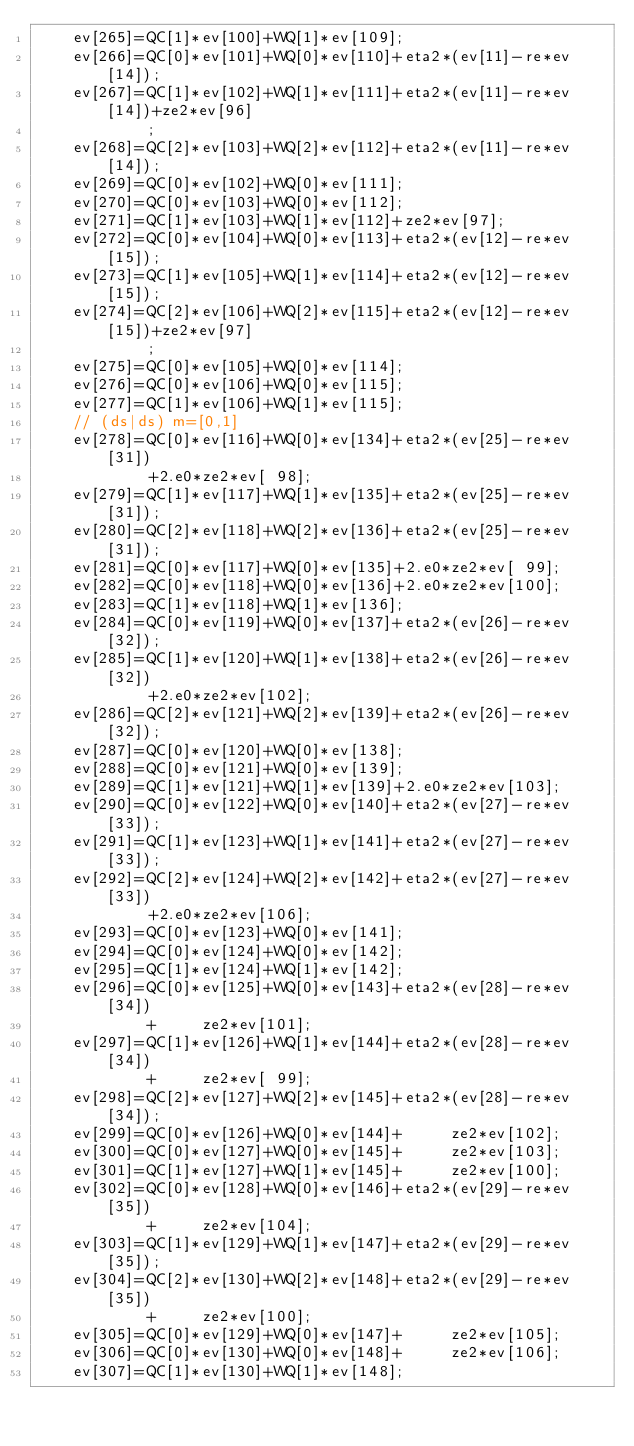<code> <loc_0><loc_0><loc_500><loc_500><_Cuda_>    ev[265]=QC[1]*ev[100]+WQ[1]*ev[109];
    ev[266]=QC[0]*ev[101]+WQ[0]*ev[110]+eta2*(ev[11]-re*ev[14]);
    ev[267]=QC[1]*ev[102]+WQ[1]*ev[111]+eta2*(ev[11]-re*ev[14])+ze2*ev[96]
            ;
    ev[268]=QC[2]*ev[103]+WQ[2]*ev[112]+eta2*(ev[11]-re*ev[14]);
    ev[269]=QC[0]*ev[102]+WQ[0]*ev[111];
    ev[270]=QC[0]*ev[103]+WQ[0]*ev[112];
    ev[271]=QC[1]*ev[103]+WQ[1]*ev[112]+ze2*ev[97];
    ev[272]=QC[0]*ev[104]+WQ[0]*ev[113]+eta2*(ev[12]-re*ev[15]);
    ev[273]=QC[1]*ev[105]+WQ[1]*ev[114]+eta2*(ev[12]-re*ev[15]);
    ev[274]=QC[2]*ev[106]+WQ[2]*ev[115]+eta2*(ev[12]-re*ev[15])+ze2*ev[97]
            ;
    ev[275]=QC[0]*ev[105]+WQ[0]*ev[114];
    ev[276]=QC[0]*ev[106]+WQ[0]*ev[115];
    ev[277]=QC[1]*ev[106]+WQ[1]*ev[115];
    // (ds|ds) m=[0,1]
    ev[278]=QC[0]*ev[116]+WQ[0]*ev[134]+eta2*(ev[25]-re*ev[31])
            +2.e0*ze2*ev[ 98];
    ev[279]=QC[1]*ev[117]+WQ[1]*ev[135]+eta2*(ev[25]-re*ev[31]);
    ev[280]=QC[2]*ev[118]+WQ[2]*ev[136]+eta2*(ev[25]-re*ev[31]);
    ev[281]=QC[0]*ev[117]+WQ[0]*ev[135]+2.e0*ze2*ev[ 99];
    ev[282]=QC[0]*ev[118]+WQ[0]*ev[136]+2.e0*ze2*ev[100];
    ev[283]=QC[1]*ev[118]+WQ[1]*ev[136];
    ev[284]=QC[0]*ev[119]+WQ[0]*ev[137]+eta2*(ev[26]-re*ev[32]);
    ev[285]=QC[1]*ev[120]+WQ[1]*ev[138]+eta2*(ev[26]-re*ev[32])
            +2.e0*ze2*ev[102];
    ev[286]=QC[2]*ev[121]+WQ[2]*ev[139]+eta2*(ev[26]-re*ev[32]);
    ev[287]=QC[0]*ev[120]+WQ[0]*ev[138];
    ev[288]=QC[0]*ev[121]+WQ[0]*ev[139];
    ev[289]=QC[1]*ev[121]+WQ[1]*ev[139]+2.e0*ze2*ev[103];
    ev[290]=QC[0]*ev[122]+WQ[0]*ev[140]+eta2*(ev[27]-re*ev[33]);
    ev[291]=QC[1]*ev[123]+WQ[1]*ev[141]+eta2*(ev[27]-re*ev[33]);
    ev[292]=QC[2]*ev[124]+WQ[2]*ev[142]+eta2*(ev[27]-re*ev[33])
            +2.e0*ze2*ev[106];
    ev[293]=QC[0]*ev[123]+WQ[0]*ev[141];
    ev[294]=QC[0]*ev[124]+WQ[0]*ev[142];
    ev[295]=QC[1]*ev[124]+WQ[1]*ev[142];
    ev[296]=QC[0]*ev[125]+WQ[0]*ev[143]+eta2*(ev[28]-re*ev[34])
            +     ze2*ev[101];
    ev[297]=QC[1]*ev[126]+WQ[1]*ev[144]+eta2*(ev[28]-re*ev[34])
            +     ze2*ev[ 99];
    ev[298]=QC[2]*ev[127]+WQ[2]*ev[145]+eta2*(ev[28]-re*ev[34]);
    ev[299]=QC[0]*ev[126]+WQ[0]*ev[144]+     ze2*ev[102];
    ev[300]=QC[0]*ev[127]+WQ[0]*ev[145]+     ze2*ev[103];
    ev[301]=QC[1]*ev[127]+WQ[1]*ev[145]+     ze2*ev[100];
    ev[302]=QC[0]*ev[128]+WQ[0]*ev[146]+eta2*(ev[29]-re*ev[35])
            +     ze2*ev[104];
    ev[303]=QC[1]*ev[129]+WQ[1]*ev[147]+eta2*(ev[29]-re*ev[35]);
    ev[304]=QC[2]*ev[130]+WQ[2]*ev[148]+eta2*(ev[29]-re*ev[35])
            +     ze2*ev[100];
    ev[305]=QC[0]*ev[129]+WQ[0]*ev[147]+     ze2*ev[105];
    ev[306]=QC[0]*ev[130]+WQ[0]*ev[148]+     ze2*ev[106];
    ev[307]=QC[1]*ev[130]+WQ[1]*ev[148];</code> 